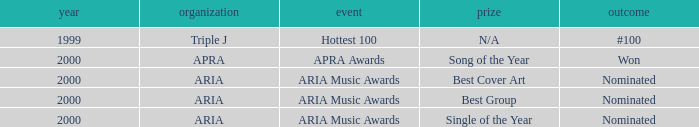What were the results before the year 2000? #100. 